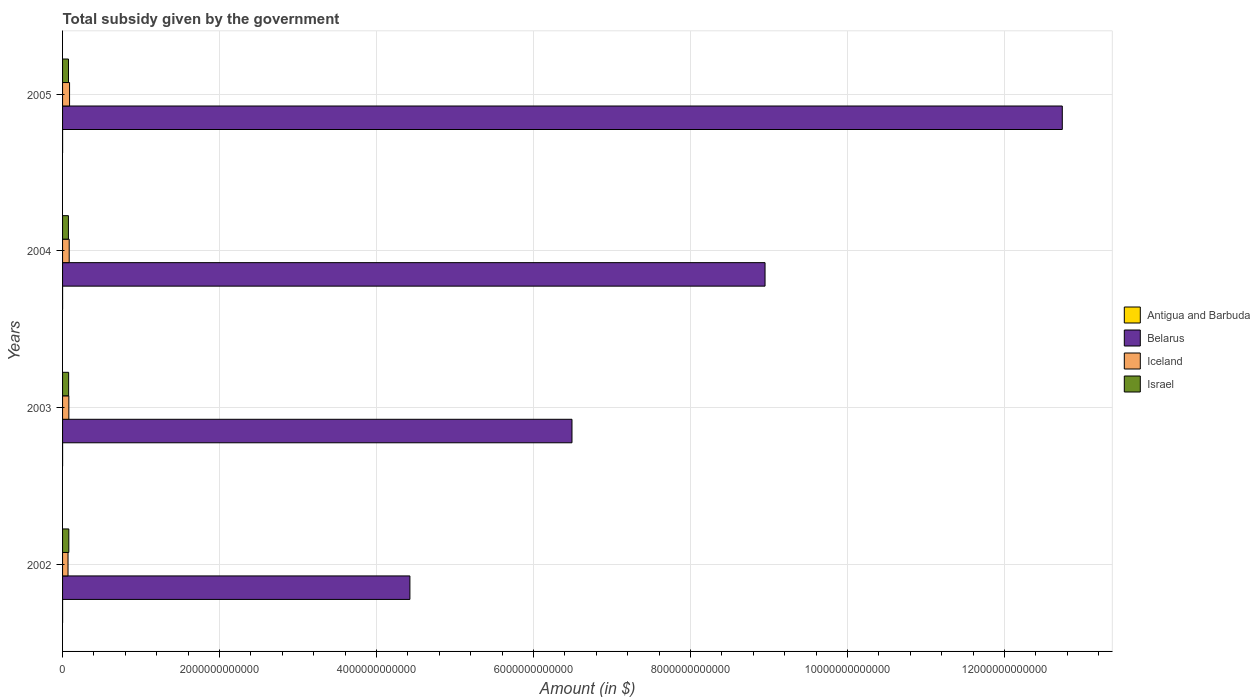How many different coloured bars are there?
Offer a terse response. 4. Are the number of bars on each tick of the Y-axis equal?
Your response must be concise. Yes. How many bars are there on the 4th tick from the bottom?
Provide a short and direct response. 4. What is the label of the 3rd group of bars from the top?
Your answer should be compact. 2003. In how many cases, is the number of bars for a given year not equal to the number of legend labels?
Provide a short and direct response. 0. What is the total revenue collected by the government in Israel in 2002?
Give a very brief answer. 7.98e+1. Across all years, what is the maximum total revenue collected by the government in Israel?
Your answer should be very brief. 7.98e+1. Across all years, what is the minimum total revenue collected by the government in Iceland?
Keep it short and to the point. 6.96e+1. In which year was the total revenue collected by the government in Antigua and Barbuda minimum?
Make the answer very short. 2002. What is the total total revenue collected by the government in Iceland in the graph?
Your response must be concise. 3.23e+11. What is the difference between the total revenue collected by the government in Israel in 2004 and that in 2005?
Give a very brief answer. -7.47e+08. What is the difference between the total revenue collected by the government in Antigua and Barbuda in 2004 and the total revenue collected by the government in Israel in 2005?
Provide a succinct answer. -7.53e+1. What is the average total revenue collected by the government in Belarus per year?
Offer a very short reply. 8.15e+12. In the year 2003, what is the difference between the total revenue collected by the government in Iceland and total revenue collected by the government in Belarus?
Provide a short and direct response. -6.41e+12. What is the ratio of the total revenue collected by the government in Antigua and Barbuda in 2002 to that in 2005?
Your response must be concise. 0.57. What is the difference between the highest and the second highest total revenue collected by the government in Antigua and Barbuda?
Offer a terse response. 2.73e+07. What is the difference between the highest and the lowest total revenue collected by the government in Israel?
Your response must be concise. 5.18e+09. In how many years, is the total revenue collected by the government in Israel greater than the average total revenue collected by the government in Israel taken over all years?
Ensure brevity in your answer.  2. Is it the case that in every year, the sum of the total revenue collected by the government in Belarus and total revenue collected by the government in Israel is greater than the total revenue collected by the government in Iceland?
Make the answer very short. Yes. How many bars are there?
Your response must be concise. 16. What is the difference between two consecutive major ticks on the X-axis?
Your answer should be very brief. 2.00e+12. Are the values on the major ticks of X-axis written in scientific E-notation?
Keep it short and to the point. No. Does the graph contain any zero values?
Keep it short and to the point. No. Where does the legend appear in the graph?
Keep it short and to the point. Center right. How many legend labels are there?
Provide a short and direct response. 4. What is the title of the graph?
Ensure brevity in your answer.  Total subsidy given by the government. What is the label or title of the X-axis?
Make the answer very short. Amount (in $). What is the Amount (in $) of Antigua and Barbuda in 2002?
Keep it short and to the point. 6.28e+07. What is the Amount (in $) in Belarus in 2002?
Ensure brevity in your answer.  4.43e+12. What is the Amount (in $) of Iceland in 2002?
Provide a short and direct response. 6.96e+1. What is the Amount (in $) of Israel in 2002?
Offer a very short reply. 7.98e+1. What is the Amount (in $) of Antigua and Barbuda in 2003?
Provide a short and direct response. 7.39e+07. What is the Amount (in $) of Belarus in 2003?
Provide a succinct answer. 6.49e+12. What is the Amount (in $) of Iceland in 2003?
Your answer should be very brief. 8.01e+1. What is the Amount (in $) in Israel in 2003?
Keep it short and to the point. 7.74e+1. What is the Amount (in $) of Antigua and Barbuda in 2004?
Offer a terse response. 8.29e+07. What is the Amount (in $) in Belarus in 2004?
Ensure brevity in your answer.  8.95e+12. What is the Amount (in $) of Iceland in 2004?
Provide a short and direct response. 8.46e+1. What is the Amount (in $) in Israel in 2004?
Ensure brevity in your answer.  7.46e+1. What is the Amount (in $) in Antigua and Barbuda in 2005?
Ensure brevity in your answer.  1.10e+08. What is the Amount (in $) of Belarus in 2005?
Offer a terse response. 1.27e+13. What is the Amount (in $) of Iceland in 2005?
Your answer should be very brief. 8.92e+1. What is the Amount (in $) in Israel in 2005?
Offer a terse response. 7.53e+1. Across all years, what is the maximum Amount (in $) in Antigua and Barbuda?
Ensure brevity in your answer.  1.10e+08. Across all years, what is the maximum Amount (in $) in Belarus?
Provide a succinct answer. 1.27e+13. Across all years, what is the maximum Amount (in $) of Iceland?
Your answer should be very brief. 8.92e+1. Across all years, what is the maximum Amount (in $) in Israel?
Give a very brief answer. 7.98e+1. Across all years, what is the minimum Amount (in $) of Antigua and Barbuda?
Your answer should be very brief. 6.28e+07. Across all years, what is the minimum Amount (in $) of Belarus?
Provide a short and direct response. 4.43e+12. Across all years, what is the minimum Amount (in $) in Iceland?
Your answer should be very brief. 6.96e+1. Across all years, what is the minimum Amount (in $) in Israel?
Provide a short and direct response. 7.46e+1. What is the total Amount (in $) of Antigua and Barbuda in the graph?
Ensure brevity in your answer.  3.30e+08. What is the total Amount (in $) in Belarus in the graph?
Give a very brief answer. 3.26e+13. What is the total Amount (in $) of Iceland in the graph?
Your answer should be compact. 3.23e+11. What is the total Amount (in $) in Israel in the graph?
Your answer should be compact. 3.07e+11. What is the difference between the Amount (in $) in Antigua and Barbuda in 2002 and that in 2003?
Make the answer very short. -1.11e+07. What is the difference between the Amount (in $) in Belarus in 2002 and that in 2003?
Make the answer very short. -2.07e+12. What is the difference between the Amount (in $) in Iceland in 2002 and that in 2003?
Offer a terse response. -1.05e+1. What is the difference between the Amount (in $) of Israel in 2002 and that in 2003?
Offer a terse response. 2.40e+09. What is the difference between the Amount (in $) in Antigua and Barbuda in 2002 and that in 2004?
Your response must be concise. -2.01e+07. What is the difference between the Amount (in $) in Belarus in 2002 and that in 2004?
Your answer should be compact. -4.52e+12. What is the difference between the Amount (in $) in Iceland in 2002 and that in 2004?
Your answer should be very brief. -1.50e+1. What is the difference between the Amount (in $) in Israel in 2002 and that in 2004?
Keep it short and to the point. 5.18e+09. What is the difference between the Amount (in $) of Antigua and Barbuda in 2002 and that in 2005?
Ensure brevity in your answer.  -4.74e+07. What is the difference between the Amount (in $) of Belarus in 2002 and that in 2005?
Keep it short and to the point. -8.31e+12. What is the difference between the Amount (in $) in Iceland in 2002 and that in 2005?
Ensure brevity in your answer.  -1.95e+1. What is the difference between the Amount (in $) of Israel in 2002 and that in 2005?
Provide a short and direct response. 4.43e+09. What is the difference between the Amount (in $) in Antigua and Barbuda in 2003 and that in 2004?
Offer a very short reply. -9.00e+06. What is the difference between the Amount (in $) in Belarus in 2003 and that in 2004?
Give a very brief answer. -2.46e+12. What is the difference between the Amount (in $) in Iceland in 2003 and that in 2004?
Your answer should be compact. -4.50e+09. What is the difference between the Amount (in $) of Israel in 2003 and that in 2004?
Keep it short and to the point. 2.78e+09. What is the difference between the Amount (in $) of Antigua and Barbuda in 2003 and that in 2005?
Make the answer very short. -3.63e+07. What is the difference between the Amount (in $) in Belarus in 2003 and that in 2005?
Provide a short and direct response. -6.25e+12. What is the difference between the Amount (in $) of Iceland in 2003 and that in 2005?
Your answer should be compact. -9.06e+09. What is the difference between the Amount (in $) in Israel in 2003 and that in 2005?
Provide a short and direct response. 2.03e+09. What is the difference between the Amount (in $) in Antigua and Barbuda in 2004 and that in 2005?
Provide a short and direct response. -2.73e+07. What is the difference between the Amount (in $) of Belarus in 2004 and that in 2005?
Offer a terse response. -3.79e+12. What is the difference between the Amount (in $) in Iceland in 2004 and that in 2005?
Offer a terse response. -4.56e+09. What is the difference between the Amount (in $) in Israel in 2004 and that in 2005?
Keep it short and to the point. -7.47e+08. What is the difference between the Amount (in $) of Antigua and Barbuda in 2002 and the Amount (in $) of Belarus in 2003?
Your response must be concise. -6.49e+12. What is the difference between the Amount (in $) of Antigua and Barbuda in 2002 and the Amount (in $) of Iceland in 2003?
Your answer should be very brief. -8.00e+1. What is the difference between the Amount (in $) in Antigua and Barbuda in 2002 and the Amount (in $) in Israel in 2003?
Offer a very short reply. -7.73e+1. What is the difference between the Amount (in $) of Belarus in 2002 and the Amount (in $) of Iceland in 2003?
Provide a succinct answer. 4.35e+12. What is the difference between the Amount (in $) in Belarus in 2002 and the Amount (in $) in Israel in 2003?
Provide a short and direct response. 4.35e+12. What is the difference between the Amount (in $) of Iceland in 2002 and the Amount (in $) of Israel in 2003?
Offer a very short reply. -7.73e+09. What is the difference between the Amount (in $) in Antigua and Barbuda in 2002 and the Amount (in $) in Belarus in 2004?
Offer a terse response. -8.95e+12. What is the difference between the Amount (in $) of Antigua and Barbuda in 2002 and the Amount (in $) of Iceland in 2004?
Provide a succinct answer. -8.45e+1. What is the difference between the Amount (in $) of Antigua and Barbuda in 2002 and the Amount (in $) of Israel in 2004?
Ensure brevity in your answer.  -7.45e+1. What is the difference between the Amount (in $) in Belarus in 2002 and the Amount (in $) in Iceland in 2004?
Give a very brief answer. 4.34e+12. What is the difference between the Amount (in $) of Belarus in 2002 and the Amount (in $) of Israel in 2004?
Keep it short and to the point. 4.35e+12. What is the difference between the Amount (in $) in Iceland in 2002 and the Amount (in $) in Israel in 2004?
Your response must be concise. -4.95e+09. What is the difference between the Amount (in $) of Antigua and Barbuda in 2002 and the Amount (in $) of Belarus in 2005?
Give a very brief answer. -1.27e+13. What is the difference between the Amount (in $) in Antigua and Barbuda in 2002 and the Amount (in $) in Iceland in 2005?
Keep it short and to the point. -8.91e+1. What is the difference between the Amount (in $) of Antigua and Barbuda in 2002 and the Amount (in $) of Israel in 2005?
Make the answer very short. -7.53e+1. What is the difference between the Amount (in $) in Belarus in 2002 and the Amount (in $) in Iceland in 2005?
Ensure brevity in your answer.  4.34e+12. What is the difference between the Amount (in $) in Belarus in 2002 and the Amount (in $) in Israel in 2005?
Give a very brief answer. 4.35e+12. What is the difference between the Amount (in $) in Iceland in 2002 and the Amount (in $) in Israel in 2005?
Offer a terse response. -5.70e+09. What is the difference between the Amount (in $) in Antigua and Barbuda in 2003 and the Amount (in $) in Belarus in 2004?
Ensure brevity in your answer.  -8.95e+12. What is the difference between the Amount (in $) of Antigua and Barbuda in 2003 and the Amount (in $) of Iceland in 2004?
Ensure brevity in your answer.  -8.45e+1. What is the difference between the Amount (in $) of Antigua and Barbuda in 2003 and the Amount (in $) of Israel in 2004?
Offer a terse response. -7.45e+1. What is the difference between the Amount (in $) in Belarus in 2003 and the Amount (in $) in Iceland in 2004?
Give a very brief answer. 6.41e+12. What is the difference between the Amount (in $) in Belarus in 2003 and the Amount (in $) in Israel in 2004?
Keep it short and to the point. 6.42e+12. What is the difference between the Amount (in $) of Iceland in 2003 and the Amount (in $) of Israel in 2004?
Your answer should be compact. 5.50e+09. What is the difference between the Amount (in $) in Antigua and Barbuda in 2003 and the Amount (in $) in Belarus in 2005?
Make the answer very short. -1.27e+13. What is the difference between the Amount (in $) of Antigua and Barbuda in 2003 and the Amount (in $) of Iceland in 2005?
Ensure brevity in your answer.  -8.91e+1. What is the difference between the Amount (in $) of Antigua and Barbuda in 2003 and the Amount (in $) of Israel in 2005?
Your response must be concise. -7.53e+1. What is the difference between the Amount (in $) in Belarus in 2003 and the Amount (in $) in Iceland in 2005?
Keep it short and to the point. 6.40e+12. What is the difference between the Amount (in $) of Belarus in 2003 and the Amount (in $) of Israel in 2005?
Provide a succinct answer. 6.41e+12. What is the difference between the Amount (in $) of Iceland in 2003 and the Amount (in $) of Israel in 2005?
Provide a succinct answer. 4.75e+09. What is the difference between the Amount (in $) of Antigua and Barbuda in 2004 and the Amount (in $) of Belarus in 2005?
Make the answer very short. -1.27e+13. What is the difference between the Amount (in $) of Antigua and Barbuda in 2004 and the Amount (in $) of Iceland in 2005?
Offer a very short reply. -8.91e+1. What is the difference between the Amount (in $) in Antigua and Barbuda in 2004 and the Amount (in $) in Israel in 2005?
Provide a short and direct response. -7.53e+1. What is the difference between the Amount (in $) in Belarus in 2004 and the Amount (in $) in Iceland in 2005?
Give a very brief answer. 8.86e+12. What is the difference between the Amount (in $) in Belarus in 2004 and the Amount (in $) in Israel in 2005?
Provide a succinct answer. 8.87e+12. What is the difference between the Amount (in $) of Iceland in 2004 and the Amount (in $) of Israel in 2005?
Your answer should be very brief. 9.25e+09. What is the average Amount (in $) in Antigua and Barbuda per year?
Offer a terse response. 8.24e+07. What is the average Amount (in $) of Belarus per year?
Your answer should be compact. 8.15e+12. What is the average Amount (in $) in Iceland per year?
Ensure brevity in your answer.  8.09e+1. What is the average Amount (in $) of Israel per year?
Provide a succinct answer. 7.68e+1. In the year 2002, what is the difference between the Amount (in $) of Antigua and Barbuda and Amount (in $) of Belarus?
Provide a short and direct response. -4.43e+12. In the year 2002, what is the difference between the Amount (in $) of Antigua and Barbuda and Amount (in $) of Iceland?
Your answer should be very brief. -6.96e+1. In the year 2002, what is the difference between the Amount (in $) of Antigua and Barbuda and Amount (in $) of Israel?
Your answer should be very brief. -7.97e+1. In the year 2002, what is the difference between the Amount (in $) of Belarus and Amount (in $) of Iceland?
Your response must be concise. 4.36e+12. In the year 2002, what is the difference between the Amount (in $) of Belarus and Amount (in $) of Israel?
Your answer should be compact. 4.35e+12. In the year 2002, what is the difference between the Amount (in $) of Iceland and Amount (in $) of Israel?
Your answer should be compact. -1.01e+1. In the year 2003, what is the difference between the Amount (in $) of Antigua and Barbuda and Amount (in $) of Belarus?
Provide a succinct answer. -6.49e+12. In the year 2003, what is the difference between the Amount (in $) of Antigua and Barbuda and Amount (in $) of Iceland?
Keep it short and to the point. -8.00e+1. In the year 2003, what is the difference between the Amount (in $) of Antigua and Barbuda and Amount (in $) of Israel?
Your answer should be very brief. -7.73e+1. In the year 2003, what is the difference between the Amount (in $) of Belarus and Amount (in $) of Iceland?
Provide a succinct answer. 6.41e+12. In the year 2003, what is the difference between the Amount (in $) in Belarus and Amount (in $) in Israel?
Keep it short and to the point. 6.41e+12. In the year 2003, what is the difference between the Amount (in $) of Iceland and Amount (in $) of Israel?
Offer a terse response. 2.73e+09. In the year 2004, what is the difference between the Amount (in $) of Antigua and Barbuda and Amount (in $) of Belarus?
Give a very brief answer. -8.95e+12. In the year 2004, what is the difference between the Amount (in $) of Antigua and Barbuda and Amount (in $) of Iceland?
Keep it short and to the point. -8.45e+1. In the year 2004, what is the difference between the Amount (in $) of Antigua and Barbuda and Amount (in $) of Israel?
Ensure brevity in your answer.  -7.45e+1. In the year 2004, what is the difference between the Amount (in $) of Belarus and Amount (in $) of Iceland?
Provide a succinct answer. 8.87e+12. In the year 2004, what is the difference between the Amount (in $) of Belarus and Amount (in $) of Israel?
Your response must be concise. 8.88e+12. In the year 2004, what is the difference between the Amount (in $) of Iceland and Amount (in $) of Israel?
Ensure brevity in your answer.  1.00e+1. In the year 2005, what is the difference between the Amount (in $) in Antigua and Barbuda and Amount (in $) in Belarus?
Provide a succinct answer. -1.27e+13. In the year 2005, what is the difference between the Amount (in $) in Antigua and Barbuda and Amount (in $) in Iceland?
Your answer should be very brief. -8.90e+1. In the year 2005, what is the difference between the Amount (in $) of Antigua and Barbuda and Amount (in $) of Israel?
Offer a very short reply. -7.52e+1. In the year 2005, what is the difference between the Amount (in $) in Belarus and Amount (in $) in Iceland?
Offer a terse response. 1.26e+13. In the year 2005, what is the difference between the Amount (in $) in Belarus and Amount (in $) in Israel?
Offer a very short reply. 1.27e+13. In the year 2005, what is the difference between the Amount (in $) in Iceland and Amount (in $) in Israel?
Ensure brevity in your answer.  1.38e+1. What is the ratio of the Amount (in $) of Antigua and Barbuda in 2002 to that in 2003?
Provide a succinct answer. 0.85. What is the ratio of the Amount (in $) of Belarus in 2002 to that in 2003?
Provide a short and direct response. 0.68. What is the ratio of the Amount (in $) of Iceland in 2002 to that in 2003?
Keep it short and to the point. 0.87. What is the ratio of the Amount (in $) of Israel in 2002 to that in 2003?
Keep it short and to the point. 1.03. What is the ratio of the Amount (in $) of Antigua and Barbuda in 2002 to that in 2004?
Ensure brevity in your answer.  0.76. What is the ratio of the Amount (in $) of Belarus in 2002 to that in 2004?
Your response must be concise. 0.49. What is the ratio of the Amount (in $) of Iceland in 2002 to that in 2004?
Make the answer very short. 0.82. What is the ratio of the Amount (in $) in Israel in 2002 to that in 2004?
Make the answer very short. 1.07. What is the ratio of the Amount (in $) of Antigua and Barbuda in 2002 to that in 2005?
Provide a short and direct response. 0.57. What is the ratio of the Amount (in $) in Belarus in 2002 to that in 2005?
Offer a terse response. 0.35. What is the ratio of the Amount (in $) of Iceland in 2002 to that in 2005?
Provide a short and direct response. 0.78. What is the ratio of the Amount (in $) in Israel in 2002 to that in 2005?
Offer a terse response. 1.06. What is the ratio of the Amount (in $) of Antigua and Barbuda in 2003 to that in 2004?
Offer a terse response. 0.89. What is the ratio of the Amount (in $) of Belarus in 2003 to that in 2004?
Your response must be concise. 0.73. What is the ratio of the Amount (in $) of Iceland in 2003 to that in 2004?
Your answer should be compact. 0.95. What is the ratio of the Amount (in $) of Israel in 2003 to that in 2004?
Offer a terse response. 1.04. What is the ratio of the Amount (in $) in Antigua and Barbuda in 2003 to that in 2005?
Provide a succinct answer. 0.67. What is the ratio of the Amount (in $) of Belarus in 2003 to that in 2005?
Make the answer very short. 0.51. What is the ratio of the Amount (in $) of Iceland in 2003 to that in 2005?
Your answer should be very brief. 0.9. What is the ratio of the Amount (in $) in Israel in 2003 to that in 2005?
Your answer should be compact. 1.03. What is the ratio of the Amount (in $) in Antigua and Barbuda in 2004 to that in 2005?
Ensure brevity in your answer.  0.75. What is the ratio of the Amount (in $) of Belarus in 2004 to that in 2005?
Keep it short and to the point. 0.7. What is the ratio of the Amount (in $) in Iceland in 2004 to that in 2005?
Give a very brief answer. 0.95. What is the ratio of the Amount (in $) in Israel in 2004 to that in 2005?
Provide a succinct answer. 0.99. What is the difference between the highest and the second highest Amount (in $) in Antigua and Barbuda?
Make the answer very short. 2.73e+07. What is the difference between the highest and the second highest Amount (in $) of Belarus?
Offer a terse response. 3.79e+12. What is the difference between the highest and the second highest Amount (in $) of Iceland?
Ensure brevity in your answer.  4.56e+09. What is the difference between the highest and the second highest Amount (in $) in Israel?
Your response must be concise. 2.40e+09. What is the difference between the highest and the lowest Amount (in $) of Antigua and Barbuda?
Make the answer very short. 4.74e+07. What is the difference between the highest and the lowest Amount (in $) in Belarus?
Keep it short and to the point. 8.31e+12. What is the difference between the highest and the lowest Amount (in $) of Iceland?
Your answer should be compact. 1.95e+1. What is the difference between the highest and the lowest Amount (in $) in Israel?
Offer a very short reply. 5.18e+09. 